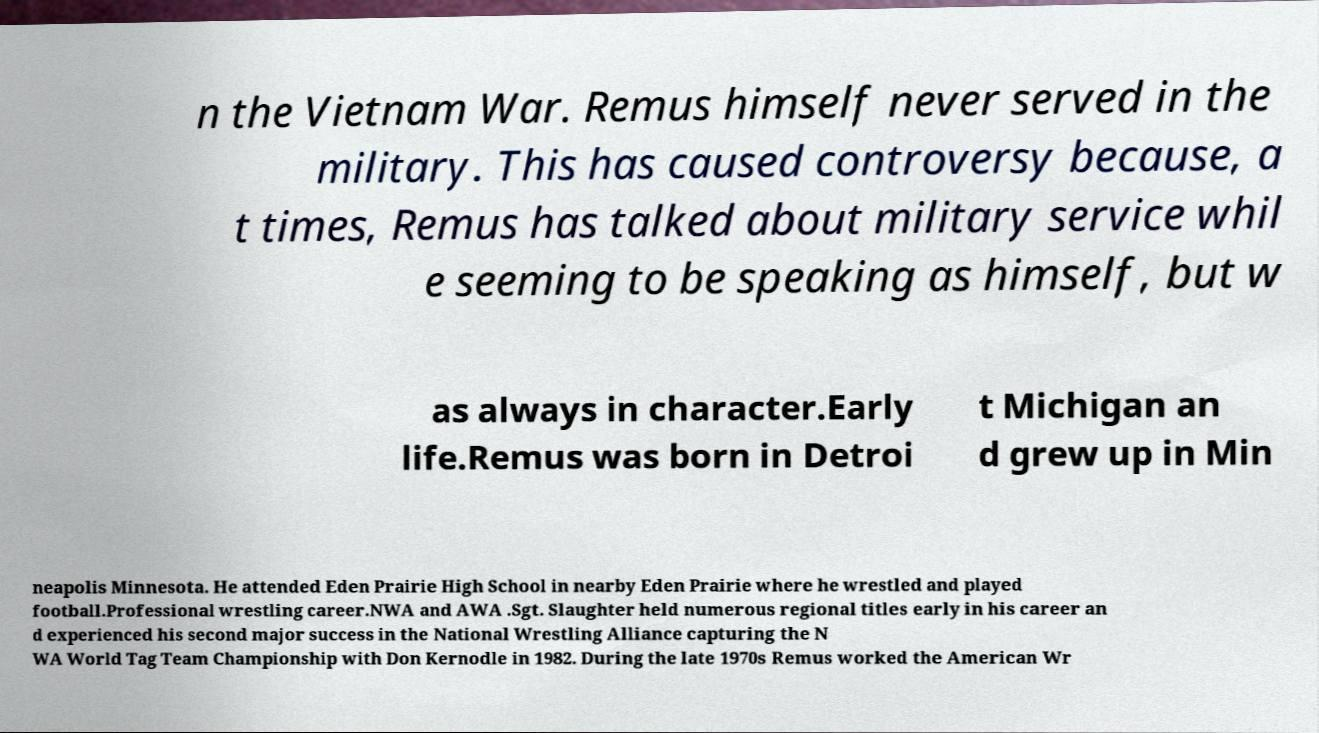Please identify and transcribe the text found in this image. n the Vietnam War. Remus himself never served in the military. This has caused controversy because, a t times, Remus has talked about military service whil e seeming to be speaking as himself, but w as always in character.Early life.Remus was born in Detroi t Michigan an d grew up in Min neapolis Minnesota. He attended Eden Prairie High School in nearby Eden Prairie where he wrestled and played football.Professional wrestling career.NWA and AWA .Sgt. Slaughter held numerous regional titles early in his career an d experienced his second major success in the National Wrestling Alliance capturing the N WA World Tag Team Championship with Don Kernodle in 1982. During the late 1970s Remus worked the American Wr 